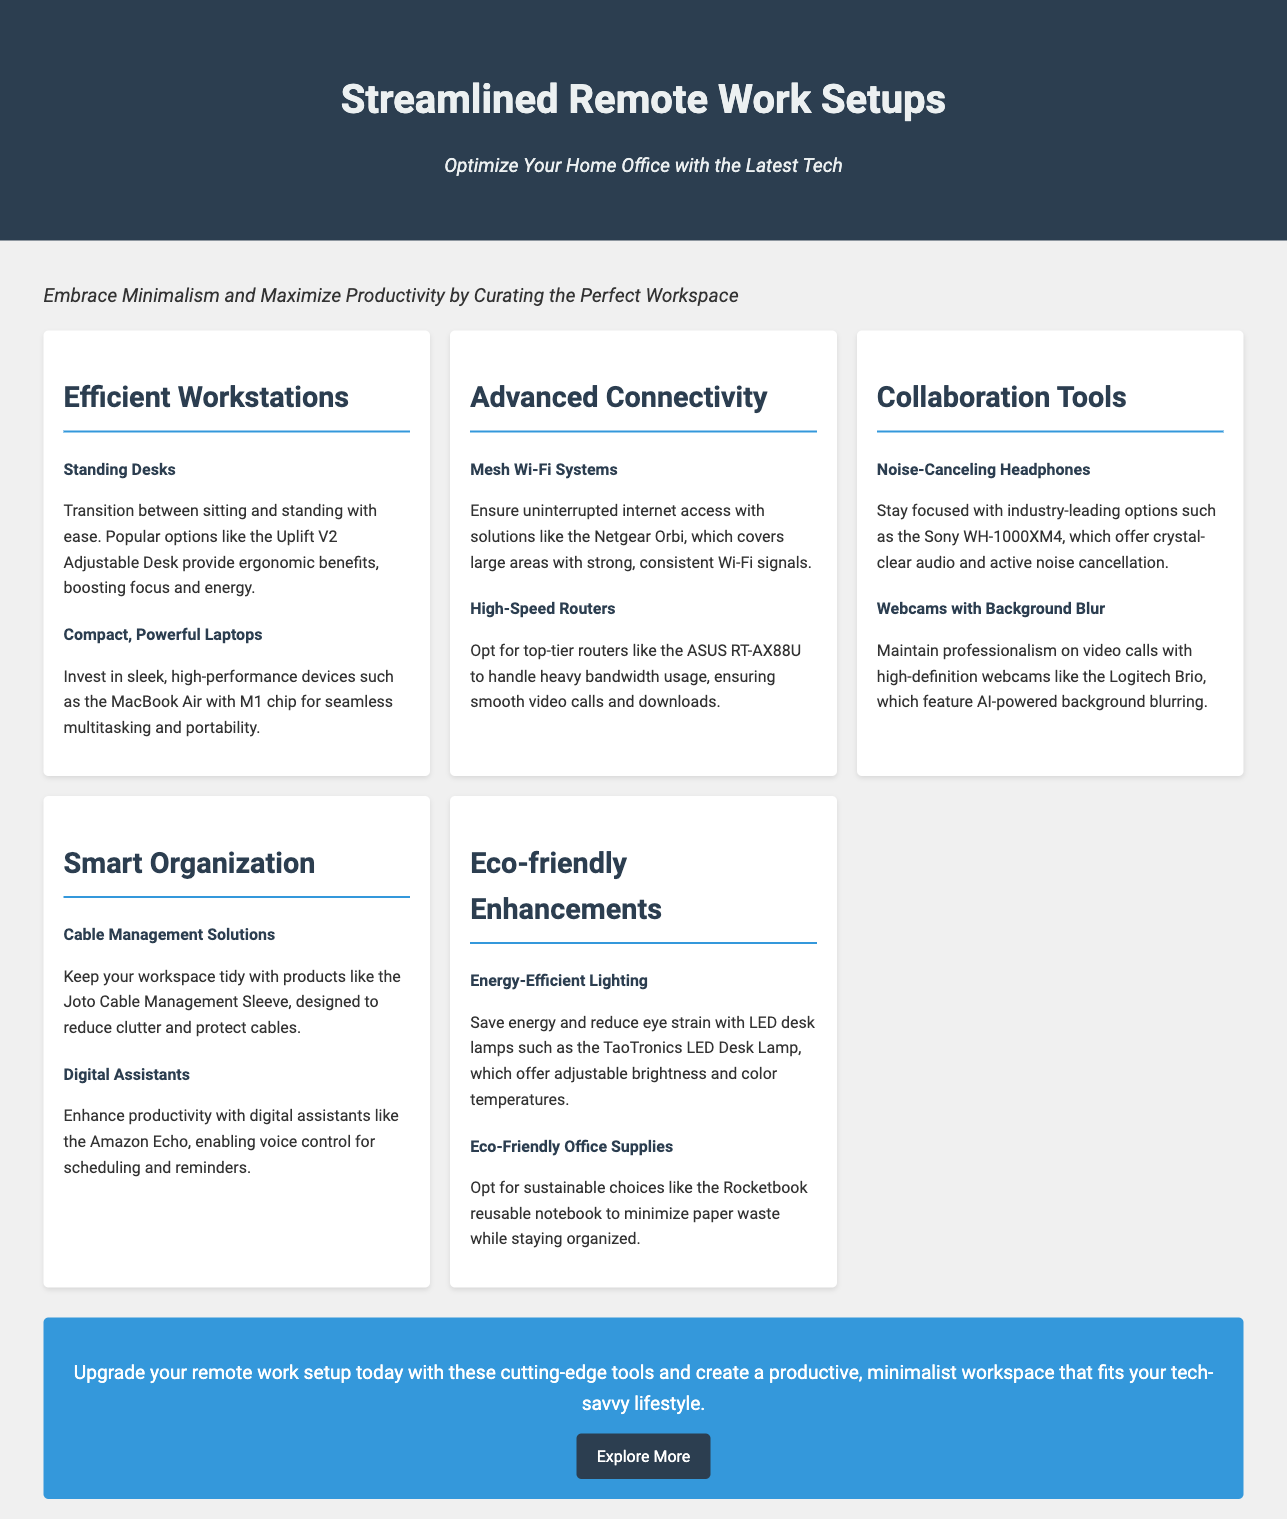What is the title of the document? The title is prominently displayed at the top of the document.
Answer: Streamlined Remote Work Setups What product is suggested for standing desks? The document mentions a specific product under the section about efficient workstations.
Answer: Uplift V2 Adjustable Desk What kind of headphones are recommended for focus? The document lists a specific type of product to help with concentration.
Answer: Noise-Canceling Headphones What is mentioned as a high-speed router option? The document lists products under advanced connectivity with a specific example.
Answer: ASUS RT-AX88U What eco-friendly office supply is suggested? The document lists items under eco-friendly enhancements with a specific example.
Answer: Rocketbook reusable notebook How does the advertisement describe the workspace theme? The overarching theme of the advertisement is summarized in the introduction.
Answer: Minimalism and Maximize Productivity What type of digital assistant is recommended? The document includes a specific product under smart organization.
Answer: Amazon Echo What lighting solution is highlighted in the eco-friendly section? The document identifies a product under eco-friendly enhancements.
Answer: TaoTronics LED Desk Lamp 